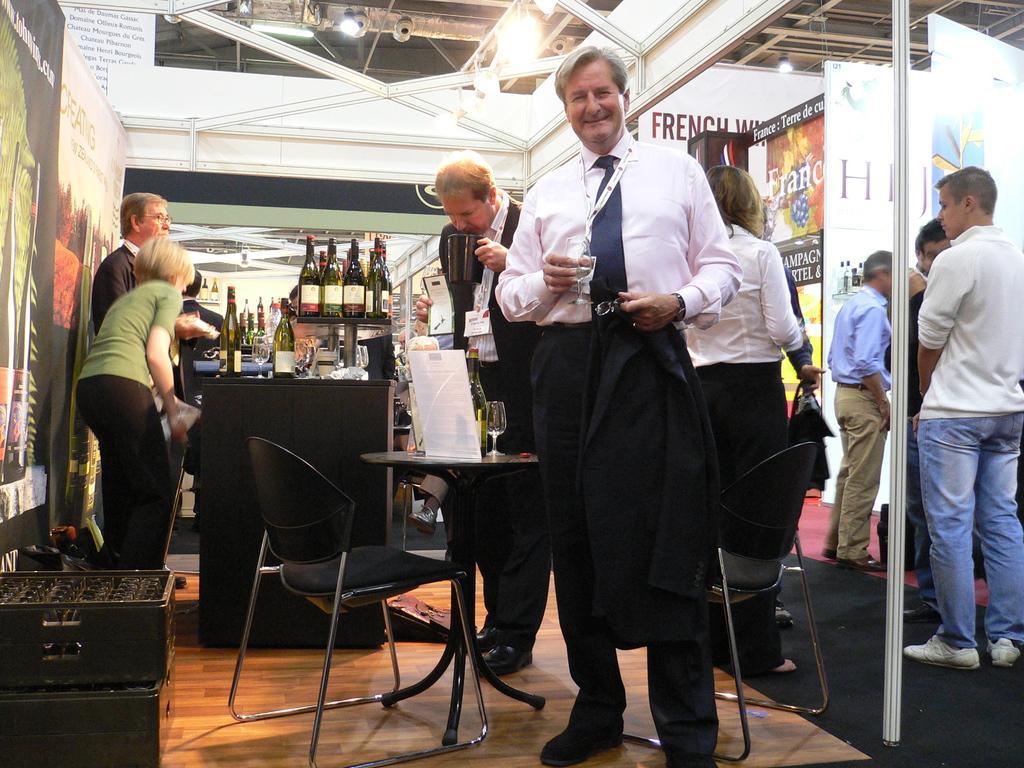Please provide a concise description of this image. In this picture there is a man in the center, he is holding a glass in one hand and blazer in another hand and he is smiling. Behind him there is a chair, table and a man holding a cup. Towards the left there are two persons standing besides a table. On the table there are group of bottles. Towards the right there are group of persons are standing. 